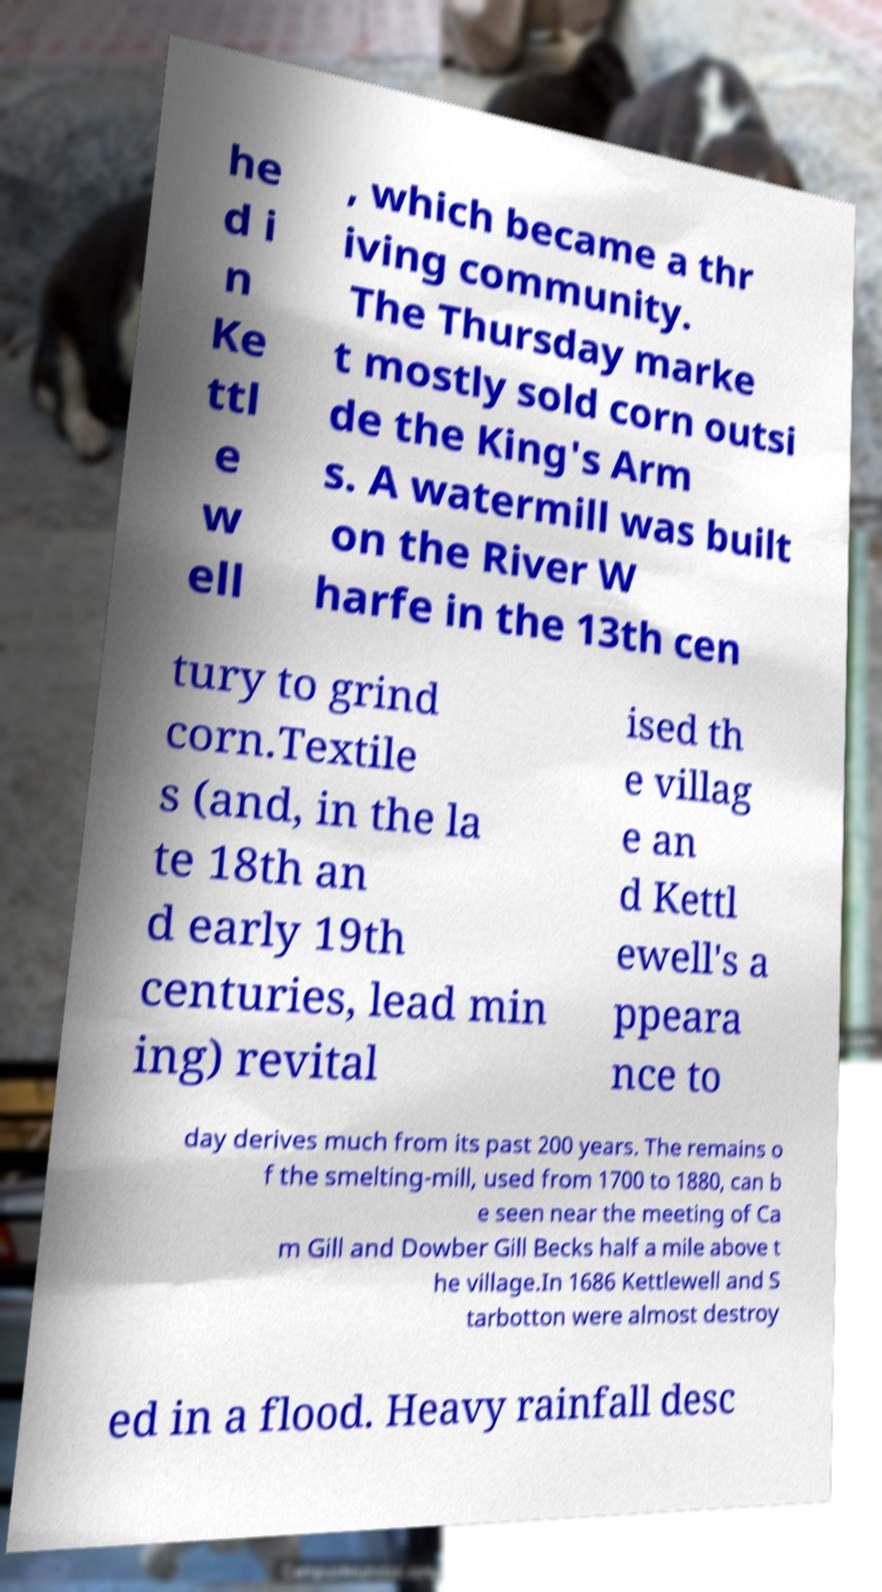Could you assist in decoding the text presented in this image and type it out clearly? he d i n Ke ttl e w ell , which became a thr iving community. The Thursday marke t mostly sold corn outsi de the King's Arm s. A watermill was built on the River W harfe in the 13th cen tury to grind corn.Textile s (and, in the la te 18th an d early 19th centuries, lead min ing) revital ised th e villag e an d Kettl ewell's a ppeara nce to day derives much from its past 200 years. The remains o f the smelting-mill, used from 1700 to 1880, can b e seen near the meeting of Ca m Gill and Dowber Gill Becks half a mile above t he village.In 1686 Kettlewell and S tarbotton were almost destroy ed in a flood. Heavy rainfall desc 